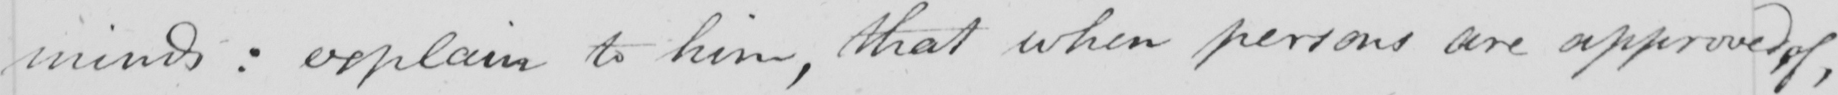Transcribe the text shown in this historical manuscript line. minds: explain to him, that when persons are approved of, 